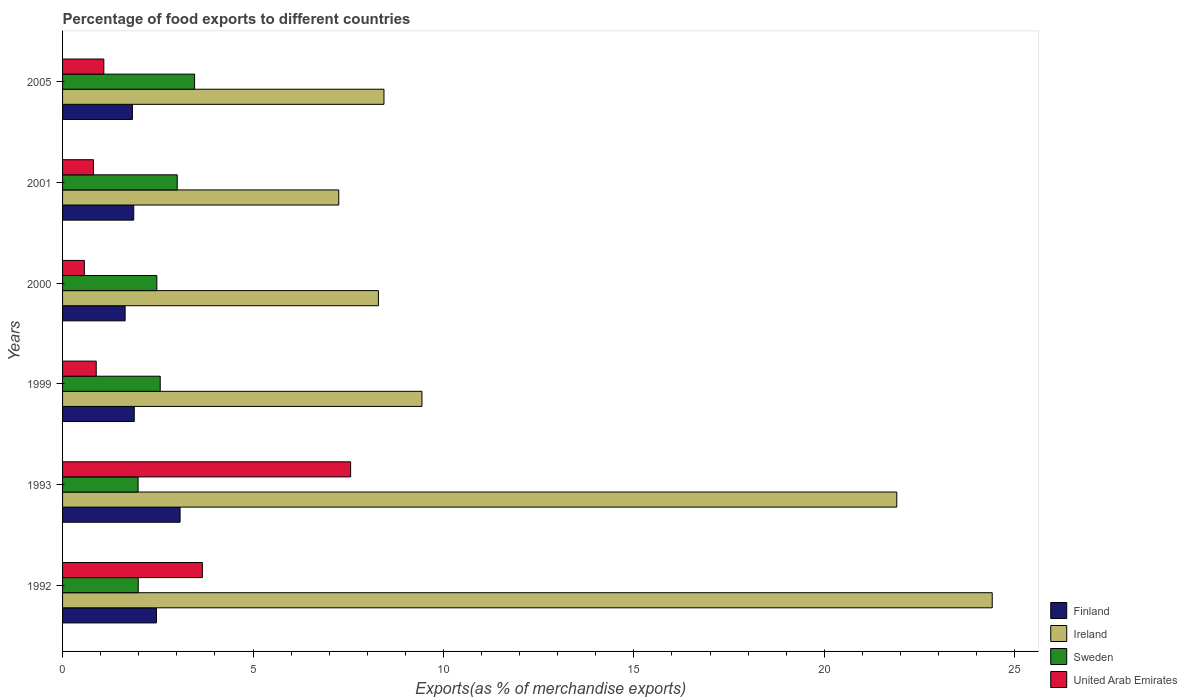How many different coloured bars are there?
Make the answer very short. 4. How many bars are there on the 6th tick from the top?
Give a very brief answer. 4. How many bars are there on the 3rd tick from the bottom?
Your answer should be very brief. 4. What is the percentage of exports to different countries in United Arab Emirates in 2000?
Make the answer very short. 0.57. Across all years, what is the maximum percentage of exports to different countries in Ireland?
Make the answer very short. 24.41. Across all years, what is the minimum percentage of exports to different countries in Ireland?
Offer a terse response. 7.25. In which year was the percentage of exports to different countries in Finland minimum?
Give a very brief answer. 2000. What is the total percentage of exports to different countries in Ireland in the graph?
Provide a short and direct response. 79.73. What is the difference between the percentage of exports to different countries in Finland in 2000 and that in 2001?
Offer a very short reply. -0.23. What is the difference between the percentage of exports to different countries in Sweden in 1993 and the percentage of exports to different countries in United Arab Emirates in 2000?
Your answer should be compact. 1.41. What is the average percentage of exports to different countries in Sweden per year?
Offer a terse response. 2.58. In the year 1993, what is the difference between the percentage of exports to different countries in United Arab Emirates and percentage of exports to different countries in Ireland?
Give a very brief answer. -14.34. What is the ratio of the percentage of exports to different countries in Ireland in 1992 to that in 2005?
Keep it short and to the point. 2.89. What is the difference between the highest and the second highest percentage of exports to different countries in Finland?
Your answer should be very brief. 0.62. What is the difference between the highest and the lowest percentage of exports to different countries in United Arab Emirates?
Offer a terse response. 6.99. Is the sum of the percentage of exports to different countries in Sweden in 2000 and 2005 greater than the maximum percentage of exports to different countries in Ireland across all years?
Keep it short and to the point. No. Is it the case that in every year, the sum of the percentage of exports to different countries in Sweden and percentage of exports to different countries in Ireland is greater than the sum of percentage of exports to different countries in United Arab Emirates and percentage of exports to different countries in Finland?
Provide a succinct answer. No. Are all the bars in the graph horizontal?
Your answer should be compact. Yes. How many years are there in the graph?
Provide a short and direct response. 6. What is the difference between two consecutive major ticks on the X-axis?
Your response must be concise. 5. Does the graph contain any zero values?
Keep it short and to the point. No. Does the graph contain grids?
Make the answer very short. No. Where does the legend appear in the graph?
Provide a succinct answer. Bottom right. What is the title of the graph?
Make the answer very short. Percentage of food exports to different countries. Does "El Salvador" appear as one of the legend labels in the graph?
Keep it short and to the point. No. What is the label or title of the X-axis?
Offer a very short reply. Exports(as % of merchandise exports). What is the Exports(as % of merchandise exports) of Finland in 1992?
Provide a short and direct response. 2.47. What is the Exports(as % of merchandise exports) in Ireland in 1992?
Ensure brevity in your answer.  24.41. What is the Exports(as % of merchandise exports) in Sweden in 1992?
Ensure brevity in your answer.  1.99. What is the Exports(as % of merchandise exports) of United Arab Emirates in 1992?
Provide a succinct answer. 3.67. What is the Exports(as % of merchandise exports) in Finland in 1993?
Your response must be concise. 3.09. What is the Exports(as % of merchandise exports) in Ireland in 1993?
Keep it short and to the point. 21.9. What is the Exports(as % of merchandise exports) of Sweden in 1993?
Give a very brief answer. 1.98. What is the Exports(as % of merchandise exports) of United Arab Emirates in 1993?
Offer a terse response. 7.56. What is the Exports(as % of merchandise exports) in Finland in 1999?
Offer a terse response. 1.88. What is the Exports(as % of merchandise exports) in Ireland in 1999?
Provide a short and direct response. 9.44. What is the Exports(as % of merchandise exports) of Sweden in 1999?
Provide a succinct answer. 2.56. What is the Exports(as % of merchandise exports) of United Arab Emirates in 1999?
Provide a succinct answer. 0.88. What is the Exports(as % of merchandise exports) of Finland in 2000?
Offer a very short reply. 1.64. What is the Exports(as % of merchandise exports) in Ireland in 2000?
Offer a terse response. 8.29. What is the Exports(as % of merchandise exports) in Sweden in 2000?
Provide a short and direct response. 2.48. What is the Exports(as % of merchandise exports) of United Arab Emirates in 2000?
Make the answer very short. 0.57. What is the Exports(as % of merchandise exports) in Finland in 2001?
Provide a succinct answer. 1.87. What is the Exports(as % of merchandise exports) in Ireland in 2001?
Your answer should be very brief. 7.25. What is the Exports(as % of merchandise exports) in Sweden in 2001?
Make the answer very short. 3.01. What is the Exports(as % of merchandise exports) in United Arab Emirates in 2001?
Provide a short and direct response. 0.81. What is the Exports(as % of merchandise exports) in Finland in 2005?
Make the answer very short. 1.83. What is the Exports(as % of merchandise exports) of Ireland in 2005?
Your answer should be compact. 8.44. What is the Exports(as % of merchandise exports) in Sweden in 2005?
Give a very brief answer. 3.47. What is the Exports(as % of merchandise exports) in United Arab Emirates in 2005?
Offer a very short reply. 1.08. Across all years, what is the maximum Exports(as % of merchandise exports) of Finland?
Give a very brief answer. 3.09. Across all years, what is the maximum Exports(as % of merchandise exports) in Ireland?
Your answer should be compact. 24.41. Across all years, what is the maximum Exports(as % of merchandise exports) in Sweden?
Offer a terse response. 3.47. Across all years, what is the maximum Exports(as % of merchandise exports) of United Arab Emirates?
Provide a succinct answer. 7.56. Across all years, what is the minimum Exports(as % of merchandise exports) of Finland?
Your answer should be very brief. 1.64. Across all years, what is the minimum Exports(as % of merchandise exports) in Ireland?
Offer a very short reply. 7.25. Across all years, what is the minimum Exports(as % of merchandise exports) in Sweden?
Make the answer very short. 1.98. Across all years, what is the minimum Exports(as % of merchandise exports) in United Arab Emirates?
Provide a succinct answer. 0.57. What is the total Exports(as % of merchandise exports) of Finland in the graph?
Keep it short and to the point. 12.78. What is the total Exports(as % of merchandise exports) of Ireland in the graph?
Give a very brief answer. 79.73. What is the total Exports(as % of merchandise exports) of Sweden in the graph?
Make the answer very short. 15.49. What is the total Exports(as % of merchandise exports) in United Arab Emirates in the graph?
Your answer should be very brief. 14.58. What is the difference between the Exports(as % of merchandise exports) of Finland in 1992 and that in 1993?
Provide a succinct answer. -0.62. What is the difference between the Exports(as % of merchandise exports) in Ireland in 1992 and that in 1993?
Your response must be concise. 2.51. What is the difference between the Exports(as % of merchandise exports) of Sweden in 1992 and that in 1993?
Ensure brevity in your answer.  0. What is the difference between the Exports(as % of merchandise exports) in United Arab Emirates in 1992 and that in 1993?
Give a very brief answer. -3.89. What is the difference between the Exports(as % of merchandise exports) of Finland in 1992 and that in 1999?
Provide a succinct answer. 0.58. What is the difference between the Exports(as % of merchandise exports) of Ireland in 1992 and that in 1999?
Provide a short and direct response. 14.97. What is the difference between the Exports(as % of merchandise exports) of Sweden in 1992 and that in 1999?
Offer a very short reply. -0.58. What is the difference between the Exports(as % of merchandise exports) in United Arab Emirates in 1992 and that in 1999?
Offer a very short reply. 2.79. What is the difference between the Exports(as % of merchandise exports) of Finland in 1992 and that in 2000?
Provide a succinct answer. 0.82. What is the difference between the Exports(as % of merchandise exports) of Ireland in 1992 and that in 2000?
Your response must be concise. 16.12. What is the difference between the Exports(as % of merchandise exports) in Sweden in 1992 and that in 2000?
Provide a succinct answer. -0.49. What is the difference between the Exports(as % of merchandise exports) in United Arab Emirates in 1992 and that in 2000?
Provide a succinct answer. 3.1. What is the difference between the Exports(as % of merchandise exports) in Finland in 1992 and that in 2001?
Provide a short and direct response. 0.6. What is the difference between the Exports(as % of merchandise exports) of Ireland in 1992 and that in 2001?
Offer a very short reply. 17.16. What is the difference between the Exports(as % of merchandise exports) in Sweden in 1992 and that in 2001?
Your response must be concise. -1.02. What is the difference between the Exports(as % of merchandise exports) in United Arab Emirates in 1992 and that in 2001?
Make the answer very short. 2.86. What is the difference between the Exports(as % of merchandise exports) in Finland in 1992 and that in 2005?
Offer a very short reply. 0.63. What is the difference between the Exports(as % of merchandise exports) of Ireland in 1992 and that in 2005?
Your response must be concise. 15.97. What is the difference between the Exports(as % of merchandise exports) of Sweden in 1992 and that in 2005?
Provide a short and direct response. -1.48. What is the difference between the Exports(as % of merchandise exports) in United Arab Emirates in 1992 and that in 2005?
Make the answer very short. 2.59. What is the difference between the Exports(as % of merchandise exports) of Finland in 1993 and that in 1999?
Give a very brief answer. 1.2. What is the difference between the Exports(as % of merchandise exports) of Ireland in 1993 and that in 1999?
Ensure brevity in your answer.  12.47. What is the difference between the Exports(as % of merchandise exports) of Sweden in 1993 and that in 1999?
Offer a terse response. -0.58. What is the difference between the Exports(as % of merchandise exports) of United Arab Emirates in 1993 and that in 1999?
Your answer should be very brief. 6.68. What is the difference between the Exports(as % of merchandise exports) in Finland in 1993 and that in 2000?
Offer a very short reply. 1.44. What is the difference between the Exports(as % of merchandise exports) of Ireland in 1993 and that in 2000?
Your answer should be very brief. 13.61. What is the difference between the Exports(as % of merchandise exports) of Sweden in 1993 and that in 2000?
Give a very brief answer. -0.49. What is the difference between the Exports(as % of merchandise exports) of United Arab Emirates in 1993 and that in 2000?
Your response must be concise. 6.99. What is the difference between the Exports(as % of merchandise exports) of Finland in 1993 and that in 2001?
Your response must be concise. 1.22. What is the difference between the Exports(as % of merchandise exports) in Ireland in 1993 and that in 2001?
Your answer should be compact. 14.65. What is the difference between the Exports(as % of merchandise exports) in Sweden in 1993 and that in 2001?
Offer a very short reply. -1.03. What is the difference between the Exports(as % of merchandise exports) of United Arab Emirates in 1993 and that in 2001?
Your answer should be very brief. 6.75. What is the difference between the Exports(as % of merchandise exports) of Finland in 1993 and that in 2005?
Your response must be concise. 1.25. What is the difference between the Exports(as % of merchandise exports) of Ireland in 1993 and that in 2005?
Ensure brevity in your answer.  13.46. What is the difference between the Exports(as % of merchandise exports) in Sweden in 1993 and that in 2005?
Your answer should be compact. -1.48. What is the difference between the Exports(as % of merchandise exports) of United Arab Emirates in 1993 and that in 2005?
Your answer should be very brief. 6.48. What is the difference between the Exports(as % of merchandise exports) in Finland in 1999 and that in 2000?
Offer a terse response. 0.24. What is the difference between the Exports(as % of merchandise exports) of Ireland in 1999 and that in 2000?
Offer a very short reply. 1.14. What is the difference between the Exports(as % of merchandise exports) in Sweden in 1999 and that in 2000?
Give a very brief answer. 0.09. What is the difference between the Exports(as % of merchandise exports) in United Arab Emirates in 1999 and that in 2000?
Offer a terse response. 0.31. What is the difference between the Exports(as % of merchandise exports) in Finland in 1999 and that in 2001?
Offer a very short reply. 0.01. What is the difference between the Exports(as % of merchandise exports) in Ireland in 1999 and that in 2001?
Provide a succinct answer. 2.18. What is the difference between the Exports(as % of merchandise exports) of Sweden in 1999 and that in 2001?
Offer a very short reply. -0.45. What is the difference between the Exports(as % of merchandise exports) of United Arab Emirates in 1999 and that in 2001?
Your answer should be very brief. 0.07. What is the difference between the Exports(as % of merchandise exports) in Finland in 1999 and that in 2005?
Offer a very short reply. 0.05. What is the difference between the Exports(as % of merchandise exports) in Ireland in 1999 and that in 2005?
Keep it short and to the point. 1. What is the difference between the Exports(as % of merchandise exports) of Sweden in 1999 and that in 2005?
Provide a succinct answer. -0.9. What is the difference between the Exports(as % of merchandise exports) of United Arab Emirates in 1999 and that in 2005?
Your answer should be very brief. -0.2. What is the difference between the Exports(as % of merchandise exports) in Finland in 2000 and that in 2001?
Provide a short and direct response. -0.23. What is the difference between the Exports(as % of merchandise exports) in Ireland in 2000 and that in 2001?
Keep it short and to the point. 1.04. What is the difference between the Exports(as % of merchandise exports) in Sweden in 2000 and that in 2001?
Offer a terse response. -0.54. What is the difference between the Exports(as % of merchandise exports) of United Arab Emirates in 2000 and that in 2001?
Your response must be concise. -0.24. What is the difference between the Exports(as % of merchandise exports) in Finland in 2000 and that in 2005?
Your answer should be compact. -0.19. What is the difference between the Exports(as % of merchandise exports) in Ireland in 2000 and that in 2005?
Give a very brief answer. -0.15. What is the difference between the Exports(as % of merchandise exports) of Sweden in 2000 and that in 2005?
Keep it short and to the point. -0.99. What is the difference between the Exports(as % of merchandise exports) in United Arab Emirates in 2000 and that in 2005?
Provide a short and direct response. -0.51. What is the difference between the Exports(as % of merchandise exports) of Finland in 2001 and that in 2005?
Ensure brevity in your answer.  0.03. What is the difference between the Exports(as % of merchandise exports) in Ireland in 2001 and that in 2005?
Your answer should be very brief. -1.19. What is the difference between the Exports(as % of merchandise exports) of Sweden in 2001 and that in 2005?
Your response must be concise. -0.46. What is the difference between the Exports(as % of merchandise exports) of United Arab Emirates in 2001 and that in 2005?
Make the answer very short. -0.27. What is the difference between the Exports(as % of merchandise exports) of Finland in 1992 and the Exports(as % of merchandise exports) of Ireland in 1993?
Make the answer very short. -19.44. What is the difference between the Exports(as % of merchandise exports) of Finland in 1992 and the Exports(as % of merchandise exports) of Sweden in 1993?
Your answer should be compact. 0.48. What is the difference between the Exports(as % of merchandise exports) of Finland in 1992 and the Exports(as % of merchandise exports) of United Arab Emirates in 1993?
Offer a terse response. -5.1. What is the difference between the Exports(as % of merchandise exports) of Ireland in 1992 and the Exports(as % of merchandise exports) of Sweden in 1993?
Keep it short and to the point. 22.43. What is the difference between the Exports(as % of merchandise exports) of Ireland in 1992 and the Exports(as % of merchandise exports) of United Arab Emirates in 1993?
Your answer should be very brief. 16.85. What is the difference between the Exports(as % of merchandise exports) in Sweden in 1992 and the Exports(as % of merchandise exports) in United Arab Emirates in 1993?
Offer a terse response. -5.58. What is the difference between the Exports(as % of merchandise exports) in Finland in 1992 and the Exports(as % of merchandise exports) in Ireland in 1999?
Your response must be concise. -6.97. What is the difference between the Exports(as % of merchandise exports) in Finland in 1992 and the Exports(as % of merchandise exports) in Sweden in 1999?
Provide a short and direct response. -0.1. What is the difference between the Exports(as % of merchandise exports) in Finland in 1992 and the Exports(as % of merchandise exports) in United Arab Emirates in 1999?
Give a very brief answer. 1.58. What is the difference between the Exports(as % of merchandise exports) of Ireland in 1992 and the Exports(as % of merchandise exports) of Sweden in 1999?
Your answer should be very brief. 21.84. What is the difference between the Exports(as % of merchandise exports) in Ireland in 1992 and the Exports(as % of merchandise exports) in United Arab Emirates in 1999?
Your answer should be compact. 23.52. What is the difference between the Exports(as % of merchandise exports) of Sweden in 1992 and the Exports(as % of merchandise exports) of United Arab Emirates in 1999?
Provide a succinct answer. 1.1. What is the difference between the Exports(as % of merchandise exports) in Finland in 1992 and the Exports(as % of merchandise exports) in Ireland in 2000?
Give a very brief answer. -5.83. What is the difference between the Exports(as % of merchandise exports) of Finland in 1992 and the Exports(as % of merchandise exports) of Sweden in 2000?
Provide a short and direct response. -0.01. What is the difference between the Exports(as % of merchandise exports) in Finland in 1992 and the Exports(as % of merchandise exports) in United Arab Emirates in 2000?
Your response must be concise. 1.89. What is the difference between the Exports(as % of merchandise exports) of Ireland in 1992 and the Exports(as % of merchandise exports) of Sweden in 2000?
Your response must be concise. 21.93. What is the difference between the Exports(as % of merchandise exports) in Ireland in 1992 and the Exports(as % of merchandise exports) in United Arab Emirates in 2000?
Provide a short and direct response. 23.84. What is the difference between the Exports(as % of merchandise exports) in Sweden in 1992 and the Exports(as % of merchandise exports) in United Arab Emirates in 2000?
Ensure brevity in your answer.  1.41. What is the difference between the Exports(as % of merchandise exports) in Finland in 1992 and the Exports(as % of merchandise exports) in Ireland in 2001?
Your answer should be very brief. -4.79. What is the difference between the Exports(as % of merchandise exports) of Finland in 1992 and the Exports(as % of merchandise exports) of Sweden in 2001?
Provide a short and direct response. -0.54. What is the difference between the Exports(as % of merchandise exports) of Finland in 1992 and the Exports(as % of merchandise exports) of United Arab Emirates in 2001?
Your answer should be compact. 1.65. What is the difference between the Exports(as % of merchandise exports) in Ireland in 1992 and the Exports(as % of merchandise exports) in Sweden in 2001?
Make the answer very short. 21.4. What is the difference between the Exports(as % of merchandise exports) in Ireland in 1992 and the Exports(as % of merchandise exports) in United Arab Emirates in 2001?
Provide a short and direct response. 23.6. What is the difference between the Exports(as % of merchandise exports) of Sweden in 1992 and the Exports(as % of merchandise exports) of United Arab Emirates in 2001?
Your response must be concise. 1.18. What is the difference between the Exports(as % of merchandise exports) in Finland in 1992 and the Exports(as % of merchandise exports) in Ireland in 2005?
Your response must be concise. -5.97. What is the difference between the Exports(as % of merchandise exports) in Finland in 1992 and the Exports(as % of merchandise exports) in Sweden in 2005?
Your answer should be very brief. -1. What is the difference between the Exports(as % of merchandise exports) of Finland in 1992 and the Exports(as % of merchandise exports) of United Arab Emirates in 2005?
Your answer should be very brief. 1.38. What is the difference between the Exports(as % of merchandise exports) in Ireland in 1992 and the Exports(as % of merchandise exports) in Sweden in 2005?
Make the answer very short. 20.94. What is the difference between the Exports(as % of merchandise exports) of Ireland in 1992 and the Exports(as % of merchandise exports) of United Arab Emirates in 2005?
Your response must be concise. 23.33. What is the difference between the Exports(as % of merchandise exports) in Sweden in 1992 and the Exports(as % of merchandise exports) in United Arab Emirates in 2005?
Offer a very short reply. 0.9. What is the difference between the Exports(as % of merchandise exports) in Finland in 1993 and the Exports(as % of merchandise exports) in Ireland in 1999?
Give a very brief answer. -6.35. What is the difference between the Exports(as % of merchandise exports) of Finland in 1993 and the Exports(as % of merchandise exports) of Sweden in 1999?
Offer a terse response. 0.52. What is the difference between the Exports(as % of merchandise exports) in Finland in 1993 and the Exports(as % of merchandise exports) in United Arab Emirates in 1999?
Your answer should be very brief. 2.2. What is the difference between the Exports(as % of merchandise exports) in Ireland in 1993 and the Exports(as % of merchandise exports) in Sweden in 1999?
Provide a short and direct response. 19.34. What is the difference between the Exports(as % of merchandise exports) of Ireland in 1993 and the Exports(as % of merchandise exports) of United Arab Emirates in 1999?
Your answer should be compact. 21.02. What is the difference between the Exports(as % of merchandise exports) in Sweden in 1993 and the Exports(as % of merchandise exports) in United Arab Emirates in 1999?
Ensure brevity in your answer.  1.1. What is the difference between the Exports(as % of merchandise exports) in Finland in 1993 and the Exports(as % of merchandise exports) in Ireland in 2000?
Your answer should be compact. -5.21. What is the difference between the Exports(as % of merchandise exports) in Finland in 1993 and the Exports(as % of merchandise exports) in Sweden in 2000?
Make the answer very short. 0.61. What is the difference between the Exports(as % of merchandise exports) in Finland in 1993 and the Exports(as % of merchandise exports) in United Arab Emirates in 2000?
Offer a terse response. 2.51. What is the difference between the Exports(as % of merchandise exports) of Ireland in 1993 and the Exports(as % of merchandise exports) of Sweden in 2000?
Offer a terse response. 19.43. What is the difference between the Exports(as % of merchandise exports) of Ireland in 1993 and the Exports(as % of merchandise exports) of United Arab Emirates in 2000?
Offer a terse response. 21.33. What is the difference between the Exports(as % of merchandise exports) of Sweden in 1993 and the Exports(as % of merchandise exports) of United Arab Emirates in 2000?
Keep it short and to the point. 1.41. What is the difference between the Exports(as % of merchandise exports) of Finland in 1993 and the Exports(as % of merchandise exports) of Ireland in 2001?
Make the answer very short. -4.17. What is the difference between the Exports(as % of merchandise exports) in Finland in 1993 and the Exports(as % of merchandise exports) in Sweden in 2001?
Make the answer very short. 0.07. What is the difference between the Exports(as % of merchandise exports) of Finland in 1993 and the Exports(as % of merchandise exports) of United Arab Emirates in 2001?
Your response must be concise. 2.27. What is the difference between the Exports(as % of merchandise exports) of Ireland in 1993 and the Exports(as % of merchandise exports) of Sweden in 2001?
Keep it short and to the point. 18.89. What is the difference between the Exports(as % of merchandise exports) in Ireland in 1993 and the Exports(as % of merchandise exports) in United Arab Emirates in 2001?
Your answer should be very brief. 21.09. What is the difference between the Exports(as % of merchandise exports) of Sweden in 1993 and the Exports(as % of merchandise exports) of United Arab Emirates in 2001?
Give a very brief answer. 1.17. What is the difference between the Exports(as % of merchandise exports) in Finland in 1993 and the Exports(as % of merchandise exports) in Ireland in 2005?
Your response must be concise. -5.35. What is the difference between the Exports(as % of merchandise exports) in Finland in 1993 and the Exports(as % of merchandise exports) in Sweden in 2005?
Provide a succinct answer. -0.38. What is the difference between the Exports(as % of merchandise exports) of Finland in 1993 and the Exports(as % of merchandise exports) of United Arab Emirates in 2005?
Keep it short and to the point. 2. What is the difference between the Exports(as % of merchandise exports) in Ireland in 1993 and the Exports(as % of merchandise exports) in Sweden in 2005?
Offer a terse response. 18.44. What is the difference between the Exports(as % of merchandise exports) in Ireland in 1993 and the Exports(as % of merchandise exports) in United Arab Emirates in 2005?
Make the answer very short. 20.82. What is the difference between the Exports(as % of merchandise exports) in Sweden in 1993 and the Exports(as % of merchandise exports) in United Arab Emirates in 2005?
Provide a short and direct response. 0.9. What is the difference between the Exports(as % of merchandise exports) of Finland in 1999 and the Exports(as % of merchandise exports) of Ireland in 2000?
Make the answer very short. -6.41. What is the difference between the Exports(as % of merchandise exports) of Finland in 1999 and the Exports(as % of merchandise exports) of Sweden in 2000?
Provide a short and direct response. -0.59. What is the difference between the Exports(as % of merchandise exports) of Finland in 1999 and the Exports(as % of merchandise exports) of United Arab Emirates in 2000?
Offer a very short reply. 1.31. What is the difference between the Exports(as % of merchandise exports) of Ireland in 1999 and the Exports(as % of merchandise exports) of Sweden in 2000?
Ensure brevity in your answer.  6.96. What is the difference between the Exports(as % of merchandise exports) of Ireland in 1999 and the Exports(as % of merchandise exports) of United Arab Emirates in 2000?
Offer a very short reply. 8.86. What is the difference between the Exports(as % of merchandise exports) of Sweden in 1999 and the Exports(as % of merchandise exports) of United Arab Emirates in 2000?
Your response must be concise. 1.99. What is the difference between the Exports(as % of merchandise exports) of Finland in 1999 and the Exports(as % of merchandise exports) of Ireland in 2001?
Your answer should be very brief. -5.37. What is the difference between the Exports(as % of merchandise exports) in Finland in 1999 and the Exports(as % of merchandise exports) in Sweden in 2001?
Your response must be concise. -1.13. What is the difference between the Exports(as % of merchandise exports) in Finland in 1999 and the Exports(as % of merchandise exports) in United Arab Emirates in 2001?
Give a very brief answer. 1.07. What is the difference between the Exports(as % of merchandise exports) of Ireland in 1999 and the Exports(as % of merchandise exports) of Sweden in 2001?
Your answer should be compact. 6.43. What is the difference between the Exports(as % of merchandise exports) in Ireland in 1999 and the Exports(as % of merchandise exports) in United Arab Emirates in 2001?
Provide a succinct answer. 8.62. What is the difference between the Exports(as % of merchandise exports) in Sweden in 1999 and the Exports(as % of merchandise exports) in United Arab Emirates in 2001?
Provide a succinct answer. 1.75. What is the difference between the Exports(as % of merchandise exports) of Finland in 1999 and the Exports(as % of merchandise exports) of Ireland in 2005?
Ensure brevity in your answer.  -6.56. What is the difference between the Exports(as % of merchandise exports) of Finland in 1999 and the Exports(as % of merchandise exports) of Sweden in 2005?
Provide a short and direct response. -1.58. What is the difference between the Exports(as % of merchandise exports) of Finland in 1999 and the Exports(as % of merchandise exports) of United Arab Emirates in 2005?
Offer a very short reply. 0.8. What is the difference between the Exports(as % of merchandise exports) of Ireland in 1999 and the Exports(as % of merchandise exports) of Sweden in 2005?
Make the answer very short. 5.97. What is the difference between the Exports(as % of merchandise exports) in Ireland in 1999 and the Exports(as % of merchandise exports) in United Arab Emirates in 2005?
Your response must be concise. 8.35. What is the difference between the Exports(as % of merchandise exports) in Sweden in 1999 and the Exports(as % of merchandise exports) in United Arab Emirates in 2005?
Provide a short and direct response. 1.48. What is the difference between the Exports(as % of merchandise exports) in Finland in 2000 and the Exports(as % of merchandise exports) in Ireland in 2001?
Ensure brevity in your answer.  -5.61. What is the difference between the Exports(as % of merchandise exports) of Finland in 2000 and the Exports(as % of merchandise exports) of Sweden in 2001?
Keep it short and to the point. -1.37. What is the difference between the Exports(as % of merchandise exports) of Finland in 2000 and the Exports(as % of merchandise exports) of United Arab Emirates in 2001?
Offer a very short reply. 0.83. What is the difference between the Exports(as % of merchandise exports) in Ireland in 2000 and the Exports(as % of merchandise exports) in Sweden in 2001?
Your response must be concise. 5.28. What is the difference between the Exports(as % of merchandise exports) in Ireland in 2000 and the Exports(as % of merchandise exports) in United Arab Emirates in 2001?
Ensure brevity in your answer.  7.48. What is the difference between the Exports(as % of merchandise exports) of Sweden in 2000 and the Exports(as % of merchandise exports) of United Arab Emirates in 2001?
Ensure brevity in your answer.  1.66. What is the difference between the Exports(as % of merchandise exports) in Finland in 2000 and the Exports(as % of merchandise exports) in Ireland in 2005?
Ensure brevity in your answer.  -6.8. What is the difference between the Exports(as % of merchandise exports) of Finland in 2000 and the Exports(as % of merchandise exports) of Sweden in 2005?
Your answer should be very brief. -1.82. What is the difference between the Exports(as % of merchandise exports) in Finland in 2000 and the Exports(as % of merchandise exports) in United Arab Emirates in 2005?
Provide a succinct answer. 0.56. What is the difference between the Exports(as % of merchandise exports) in Ireland in 2000 and the Exports(as % of merchandise exports) in Sweden in 2005?
Your answer should be very brief. 4.83. What is the difference between the Exports(as % of merchandise exports) in Ireland in 2000 and the Exports(as % of merchandise exports) in United Arab Emirates in 2005?
Your answer should be very brief. 7.21. What is the difference between the Exports(as % of merchandise exports) of Sweden in 2000 and the Exports(as % of merchandise exports) of United Arab Emirates in 2005?
Offer a terse response. 1.39. What is the difference between the Exports(as % of merchandise exports) in Finland in 2001 and the Exports(as % of merchandise exports) in Ireland in 2005?
Provide a short and direct response. -6.57. What is the difference between the Exports(as % of merchandise exports) of Finland in 2001 and the Exports(as % of merchandise exports) of Sweden in 2005?
Your response must be concise. -1.6. What is the difference between the Exports(as % of merchandise exports) of Finland in 2001 and the Exports(as % of merchandise exports) of United Arab Emirates in 2005?
Offer a terse response. 0.79. What is the difference between the Exports(as % of merchandise exports) of Ireland in 2001 and the Exports(as % of merchandise exports) of Sweden in 2005?
Provide a short and direct response. 3.79. What is the difference between the Exports(as % of merchandise exports) in Ireland in 2001 and the Exports(as % of merchandise exports) in United Arab Emirates in 2005?
Your answer should be very brief. 6.17. What is the difference between the Exports(as % of merchandise exports) in Sweden in 2001 and the Exports(as % of merchandise exports) in United Arab Emirates in 2005?
Offer a very short reply. 1.93. What is the average Exports(as % of merchandise exports) in Finland per year?
Keep it short and to the point. 2.13. What is the average Exports(as % of merchandise exports) of Ireland per year?
Provide a succinct answer. 13.29. What is the average Exports(as % of merchandise exports) of Sweden per year?
Make the answer very short. 2.58. What is the average Exports(as % of merchandise exports) in United Arab Emirates per year?
Offer a terse response. 2.43. In the year 1992, what is the difference between the Exports(as % of merchandise exports) in Finland and Exports(as % of merchandise exports) in Ireland?
Provide a short and direct response. -21.94. In the year 1992, what is the difference between the Exports(as % of merchandise exports) in Finland and Exports(as % of merchandise exports) in Sweden?
Your answer should be very brief. 0.48. In the year 1992, what is the difference between the Exports(as % of merchandise exports) of Finland and Exports(as % of merchandise exports) of United Arab Emirates?
Offer a very short reply. -1.2. In the year 1992, what is the difference between the Exports(as % of merchandise exports) of Ireland and Exports(as % of merchandise exports) of Sweden?
Provide a short and direct response. 22.42. In the year 1992, what is the difference between the Exports(as % of merchandise exports) in Ireland and Exports(as % of merchandise exports) in United Arab Emirates?
Provide a succinct answer. 20.74. In the year 1992, what is the difference between the Exports(as % of merchandise exports) in Sweden and Exports(as % of merchandise exports) in United Arab Emirates?
Ensure brevity in your answer.  -1.68. In the year 1993, what is the difference between the Exports(as % of merchandise exports) in Finland and Exports(as % of merchandise exports) in Ireland?
Provide a short and direct response. -18.82. In the year 1993, what is the difference between the Exports(as % of merchandise exports) of Finland and Exports(as % of merchandise exports) of Sweden?
Provide a short and direct response. 1.1. In the year 1993, what is the difference between the Exports(as % of merchandise exports) of Finland and Exports(as % of merchandise exports) of United Arab Emirates?
Offer a very short reply. -4.48. In the year 1993, what is the difference between the Exports(as % of merchandise exports) in Ireland and Exports(as % of merchandise exports) in Sweden?
Give a very brief answer. 19.92. In the year 1993, what is the difference between the Exports(as % of merchandise exports) of Ireland and Exports(as % of merchandise exports) of United Arab Emirates?
Offer a terse response. 14.34. In the year 1993, what is the difference between the Exports(as % of merchandise exports) in Sweden and Exports(as % of merchandise exports) in United Arab Emirates?
Offer a very short reply. -5.58. In the year 1999, what is the difference between the Exports(as % of merchandise exports) in Finland and Exports(as % of merchandise exports) in Ireland?
Make the answer very short. -7.55. In the year 1999, what is the difference between the Exports(as % of merchandise exports) in Finland and Exports(as % of merchandise exports) in Sweden?
Offer a very short reply. -0.68. In the year 1999, what is the difference between the Exports(as % of merchandise exports) of Finland and Exports(as % of merchandise exports) of United Arab Emirates?
Your answer should be compact. 1. In the year 1999, what is the difference between the Exports(as % of merchandise exports) in Ireland and Exports(as % of merchandise exports) in Sweden?
Your answer should be compact. 6.87. In the year 1999, what is the difference between the Exports(as % of merchandise exports) in Ireland and Exports(as % of merchandise exports) in United Arab Emirates?
Your response must be concise. 8.55. In the year 1999, what is the difference between the Exports(as % of merchandise exports) in Sweden and Exports(as % of merchandise exports) in United Arab Emirates?
Offer a very short reply. 1.68. In the year 2000, what is the difference between the Exports(as % of merchandise exports) of Finland and Exports(as % of merchandise exports) of Ireland?
Offer a terse response. -6.65. In the year 2000, what is the difference between the Exports(as % of merchandise exports) in Finland and Exports(as % of merchandise exports) in Sweden?
Give a very brief answer. -0.83. In the year 2000, what is the difference between the Exports(as % of merchandise exports) in Finland and Exports(as % of merchandise exports) in United Arab Emirates?
Make the answer very short. 1.07. In the year 2000, what is the difference between the Exports(as % of merchandise exports) of Ireland and Exports(as % of merchandise exports) of Sweden?
Offer a terse response. 5.82. In the year 2000, what is the difference between the Exports(as % of merchandise exports) in Ireland and Exports(as % of merchandise exports) in United Arab Emirates?
Make the answer very short. 7.72. In the year 2000, what is the difference between the Exports(as % of merchandise exports) in Sweden and Exports(as % of merchandise exports) in United Arab Emirates?
Your answer should be compact. 1.9. In the year 2001, what is the difference between the Exports(as % of merchandise exports) in Finland and Exports(as % of merchandise exports) in Ireland?
Your answer should be very brief. -5.38. In the year 2001, what is the difference between the Exports(as % of merchandise exports) in Finland and Exports(as % of merchandise exports) in Sweden?
Give a very brief answer. -1.14. In the year 2001, what is the difference between the Exports(as % of merchandise exports) of Finland and Exports(as % of merchandise exports) of United Arab Emirates?
Your response must be concise. 1.06. In the year 2001, what is the difference between the Exports(as % of merchandise exports) in Ireland and Exports(as % of merchandise exports) in Sweden?
Your response must be concise. 4.24. In the year 2001, what is the difference between the Exports(as % of merchandise exports) of Ireland and Exports(as % of merchandise exports) of United Arab Emirates?
Your answer should be very brief. 6.44. In the year 2001, what is the difference between the Exports(as % of merchandise exports) in Sweden and Exports(as % of merchandise exports) in United Arab Emirates?
Provide a succinct answer. 2.2. In the year 2005, what is the difference between the Exports(as % of merchandise exports) of Finland and Exports(as % of merchandise exports) of Ireland?
Your answer should be compact. -6.6. In the year 2005, what is the difference between the Exports(as % of merchandise exports) of Finland and Exports(as % of merchandise exports) of Sweden?
Ensure brevity in your answer.  -1.63. In the year 2005, what is the difference between the Exports(as % of merchandise exports) in Finland and Exports(as % of merchandise exports) in United Arab Emirates?
Make the answer very short. 0.75. In the year 2005, what is the difference between the Exports(as % of merchandise exports) in Ireland and Exports(as % of merchandise exports) in Sweden?
Your answer should be compact. 4.97. In the year 2005, what is the difference between the Exports(as % of merchandise exports) in Ireland and Exports(as % of merchandise exports) in United Arab Emirates?
Your response must be concise. 7.36. In the year 2005, what is the difference between the Exports(as % of merchandise exports) of Sweden and Exports(as % of merchandise exports) of United Arab Emirates?
Give a very brief answer. 2.38. What is the ratio of the Exports(as % of merchandise exports) of Finland in 1992 to that in 1993?
Make the answer very short. 0.8. What is the ratio of the Exports(as % of merchandise exports) in Ireland in 1992 to that in 1993?
Provide a succinct answer. 1.11. What is the ratio of the Exports(as % of merchandise exports) in United Arab Emirates in 1992 to that in 1993?
Give a very brief answer. 0.49. What is the ratio of the Exports(as % of merchandise exports) in Finland in 1992 to that in 1999?
Offer a very short reply. 1.31. What is the ratio of the Exports(as % of merchandise exports) of Ireland in 1992 to that in 1999?
Give a very brief answer. 2.59. What is the ratio of the Exports(as % of merchandise exports) of Sweden in 1992 to that in 1999?
Your response must be concise. 0.77. What is the ratio of the Exports(as % of merchandise exports) in United Arab Emirates in 1992 to that in 1999?
Keep it short and to the point. 4.15. What is the ratio of the Exports(as % of merchandise exports) in Finland in 1992 to that in 2000?
Offer a very short reply. 1.5. What is the ratio of the Exports(as % of merchandise exports) in Ireland in 1992 to that in 2000?
Your answer should be very brief. 2.94. What is the ratio of the Exports(as % of merchandise exports) in Sweden in 1992 to that in 2000?
Your answer should be compact. 0.8. What is the ratio of the Exports(as % of merchandise exports) of United Arab Emirates in 1992 to that in 2000?
Make the answer very short. 6.41. What is the ratio of the Exports(as % of merchandise exports) in Finland in 1992 to that in 2001?
Keep it short and to the point. 1.32. What is the ratio of the Exports(as % of merchandise exports) of Ireland in 1992 to that in 2001?
Offer a very short reply. 3.37. What is the ratio of the Exports(as % of merchandise exports) in Sweden in 1992 to that in 2001?
Offer a very short reply. 0.66. What is the ratio of the Exports(as % of merchandise exports) in United Arab Emirates in 1992 to that in 2001?
Make the answer very short. 4.52. What is the ratio of the Exports(as % of merchandise exports) of Finland in 1992 to that in 2005?
Offer a terse response. 1.34. What is the ratio of the Exports(as % of merchandise exports) of Ireland in 1992 to that in 2005?
Provide a succinct answer. 2.89. What is the ratio of the Exports(as % of merchandise exports) of Sweden in 1992 to that in 2005?
Provide a short and direct response. 0.57. What is the ratio of the Exports(as % of merchandise exports) in United Arab Emirates in 1992 to that in 2005?
Your answer should be compact. 3.39. What is the ratio of the Exports(as % of merchandise exports) of Finland in 1993 to that in 1999?
Provide a succinct answer. 1.64. What is the ratio of the Exports(as % of merchandise exports) in Ireland in 1993 to that in 1999?
Offer a very short reply. 2.32. What is the ratio of the Exports(as % of merchandise exports) of Sweden in 1993 to that in 1999?
Make the answer very short. 0.77. What is the ratio of the Exports(as % of merchandise exports) of United Arab Emirates in 1993 to that in 1999?
Give a very brief answer. 8.56. What is the ratio of the Exports(as % of merchandise exports) of Finland in 1993 to that in 2000?
Give a very brief answer. 1.88. What is the ratio of the Exports(as % of merchandise exports) in Ireland in 1993 to that in 2000?
Offer a very short reply. 2.64. What is the ratio of the Exports(as % of merchandise exports) of Sweden in 1993 to that in 2000?
Provide a short and direct response. 0.8. What is the ratio of the Exports(as % of merchandise exports) of United Arab Emirates in 1993 to that in 2000?
Give a very brief answer. 13.22. What is the ratio of the Exports(as % of merchandise exports) in Finland in 1993 to that in 2001?
Keep it short and to the point. 1.65. What is the ratio of the Exports(as % of merchandise exports) in Ireland in 1993 to that in 2001?
Provide a succinct answer. 3.02. What is the ratio of the Exports(as % of merchandise exports) in Sweden in 1993 to that in 2001?
Give a very brief answer. 0.66. What is the ratio of the Exports(as % of merchandise exports) in United Arab Emirates in 1993 to that in 2001?
Provide a succinct answer. 9.32. What is the ratio of the Exports(as % of merchandise exports) in Finland in 1993 to that in 2005?
Provide a succinct answer. 1.68. What is the ratio of the Exports(as % of merchandise exports) of Ireland in 1993 to that in 2005?
Make the answer very short. 2.6. What is the ratio of the Exports(as % of merchandise exports) of Sweden in 1993 to that in 2005?
Your answer should be very brief. 0.57. What is the ratio of the Exports(as % of merchandise exports) in United Arab Emirates in 1993 to that in 2005?
Offer a terse response. 6.98. What is the ratio of the Exports(as % of merchandise exports) in Finland in 1999 to that in 2000?
Keep it short and to the point. 1.15. What is the ratio of the Exports(as % of merchandise exports) in Ireland in 1999 to that in 2000?
Offer a very short reply. 1.14. What is the ratio of the Exports(as % of merchandise exports) of Sweden in 1999 to that in 2000?
Offer a very short reply. 1.04. What is the ratio of the Exports(as % of merchandise exports) in United Arab Emirates in 1999 to that in 2000?
Offer a very short reply. 1.54. What is the ratio of the Exports(as % of merchandise exports) in Finland in 1999 to that in 2001?
Offer a very short reply. 1.01. What is the ratio of the Exports(as % of merchandise exports) in Ireland in 1999 to that in 2001?
Keep it short and to the point. 1.3. What is the ratio of the Exports(as % of merchandise exports) of Sweden in 1999 to that in 2001?
Provide a short and direct response. 0.85. What is the ratio of the Exports(as % of merchandise exports) of United Arab Emirates in 1999 to that in 2001?
Provide a succinct answer. 1.09. What is the ratio of the Exports(as % of merchandise exports) of Finland in 1999 to that in 2005?
Your answer should be very brief. 1.03. What is the ratio of the Exports(as % of merchandise exports) of Ireland in 1999 to that in 2005?
Your answer should be very brief. 1.12. What is the ratio of the Exports(as % of merchandise exports) of Sweden in 1999 to that in 2005?
Your response must be concise. 0.74. What is the ratio of the Exports(as % of merchandise exports) of United Arab Emirates in 1999 to that in 2005?
Your answer should be compact. 0.82. What is the ratio of the Exports(as % of merchandise exports) of Finland in 2000 to that in 2001?
Offer a very short reply. 0.88. What is the ratio of the Exports(as % of merchandise exports) in Ireland in 2000 to that in 2001?
Your response must be concise. 1.14. What is the ratio of the Exports(as % of merchandise exports) in Sweden in 2000 to that in 2001?
Make the answer very short. 0.82. What is the ratio of the Exports(as % of merchandise exports) of United Arab Emirates in 2000 to that in 2001?
Provide a succinct answer. 0.71. What is the ratio of the Exports(as % of merchandise exports) in Finland in 2000 to that in 2005?
Give a very brief answer. 0.9. What is the ratio of the Exports(as % of merchandise exports) of Ireland in 2000 to that in 2005?
Your answer should be compact. 0.98. What is the ratio of the Exports(as % of merchandise exports) in Sweden in 2000 to that in 2005?
Give a very brief answer. 0.71. What is the ratio of the Exports(as % of merchandise exports) of United Arab Emirates in 2000 to that in 2005?
Offer a very short reply. 0.53. What is the ratio of the Exports(as % of merchandise exports) of Finland in 2001 to that in 2005?
Ensure brevity in your answer.  1.02. What is the ratio of the Exports(as % of merchandise exports) in Ireland in 2001 to that in 2005?
Your response must be concise. 0.86. What is the ratio of the Exports(as % of merchandise exports) of Sweden in 2001 to that in 2005?
Your answer should be very brief. 0.87. What is the ratio of the Exports(as % of merchandise exports) of United Arab Emirates in 2001 to that in 2005?
Ensure brevity in your answer.  0.75. What is the difference between the highest and the second highest Exports(as % of merchandise exports) of Finland?
Your answer should be very brief. 0.62. What is the difference between the highest and the second highest Exports(as % of merchandise exports) of Ireland?
Provide a succinct answer. 2.51. What is the difference between the highest and the second highest Exports(as % of merchandise exports) of Sweden?
Provide a succinct answer. 0.46. What is the difference between the highest and the second highest Exports(as % of merchandise exports) of United Arab Emirates?
Offer a very short reply. 3.89. What is the difference between the highest and the lowest Exports(as % of merchandise exports) of Finland?
Provide a succinct answer. 1.44. What is the difference between the highest and the lowest Exports(as % of merchandise exports) in Ireland?
Your answer should be very brief. 17.16. What is the difference between the highest and the lowest Exports(as % of merchandise exports) of Sweden?
Provide a short and direct response. 1.48. What is the difference between the highest and the lowest Exports(as % of merchandise exports) of United Arab Emirates?
Your response must be concise. 6.99. 